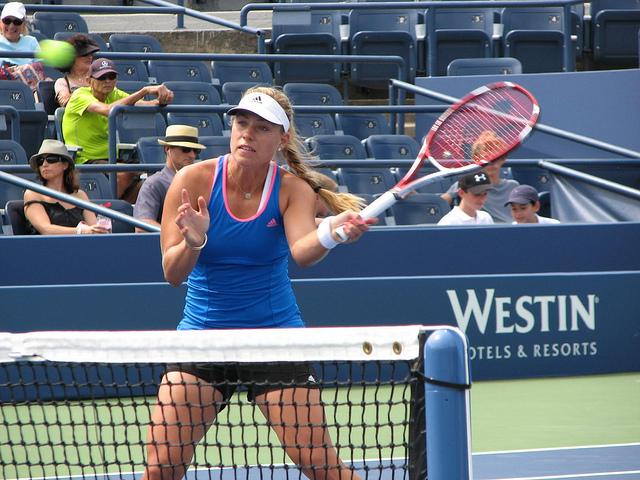What sport is this?
Answer briefly. Tennis. What is the sponsor of the tournament?
Give a very brief answer. Westin. Which brand of hotels is being advertised?
Keep it brief. Westin. 